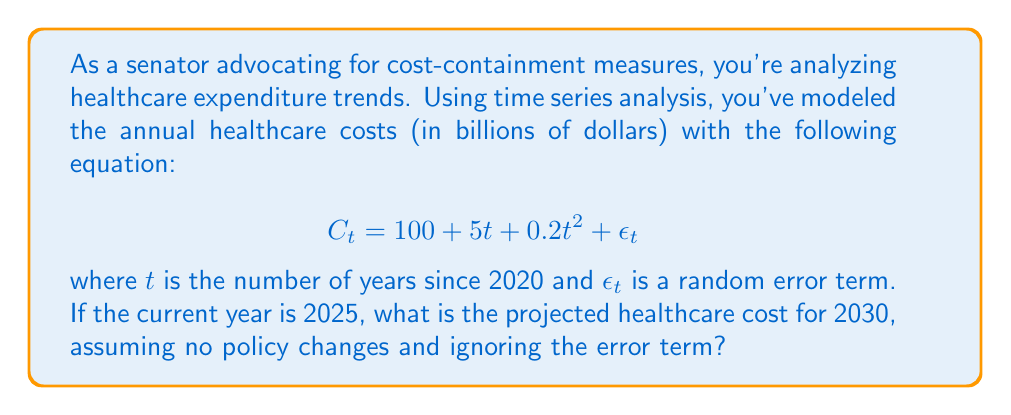Give your solution to this math problem. To solve this problem, we'll follow these steps:

1. Identify the year we're forecasting:
   2030 is 10 years after 2020, so $t = 10$

2. Substitute $t = 10$ into the given equation:
   $$C_{10} = 100 + 5(10) + 0.2(10)^2 + \epsilon_{10}$$

3. Simplify the equation:
   $$C_{10} = 100 + 50 + 0.2(100) + \epsilon_{10}$$
   $$C_{10} = 100 + 50 + 20 + \epsilon_{10}$$
   $$C_{10} = 170 + \epsilon_{10}$$

4. Ignore the error term as specified in the question:
   $$C_{10} = 170$$

Therefore, the projected healthcare cost for 2030 is 170 billion dollars.
Answer: $170 billion 